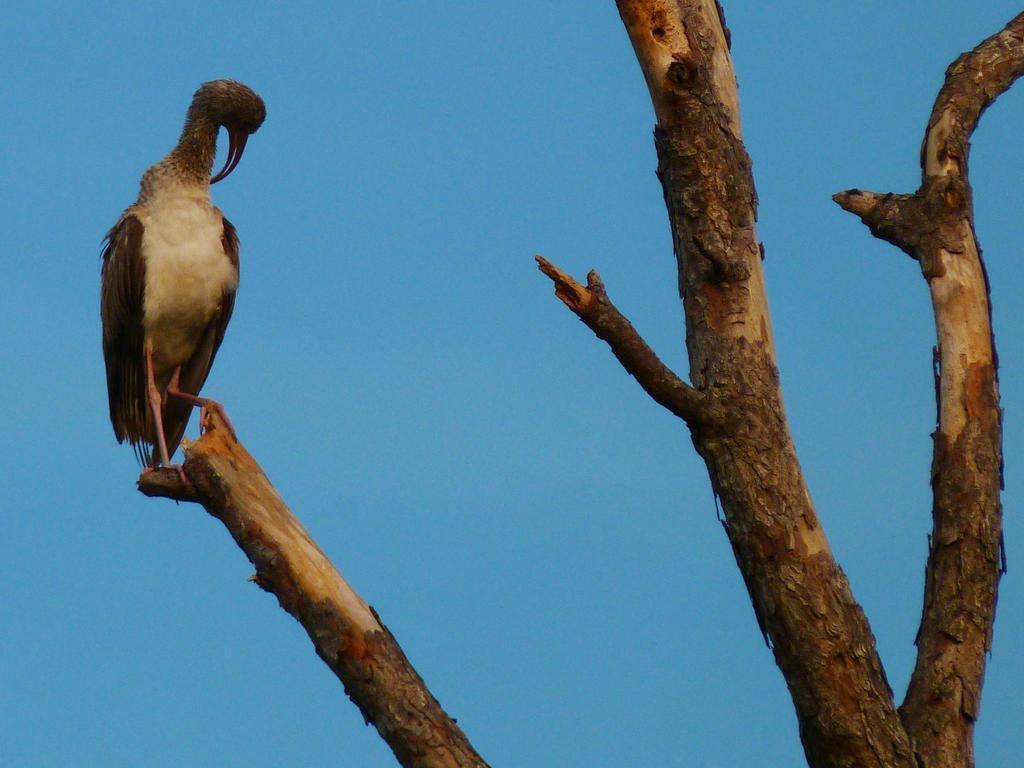In one or two sentences, can you explain what this image depicts? In this image we can see a bird is sitting on the tree. The sky is in blue color. 